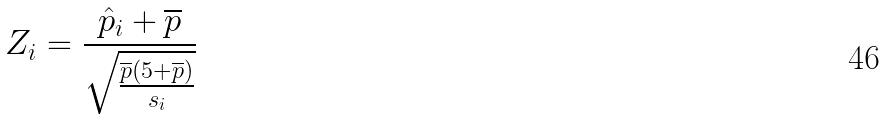<formula> <loc_0><loc_0><loc_500><loc_500>Z _ { i } = \frac { \hat { p } _ { i } + \overline { p } } { \sqrt { \frac { \overline { p } ( 5 + \overline { p } ) } { s _ { i } } } }</formula> 